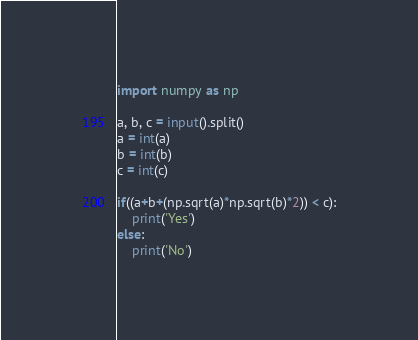Convert code to text. <code><loc_0><loc_0><loc_500><loc_500><_Python_>import numpy as np

a, b, c = input().split()
a = int(a)
b = int(b)
c = int(c)

if((a+b+(np.sqrt(a)*np.sqrt(b)*2)) < c):
	print('Yes')
else:
	print('No')
</code> 